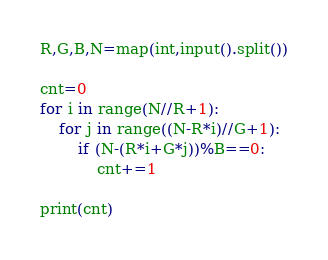Convert code to text. <code><loc_0><loc_0><loc_500><loc_500><_Python_>R,G,B,N=map(int,input().split())

cnt=0
for i in range(N//R+1):
    for j in range((N-R*i)//G+1):
        if (N-(R*i+G*j))%B==0:
            cnt+=1

print(cnt)</code> 